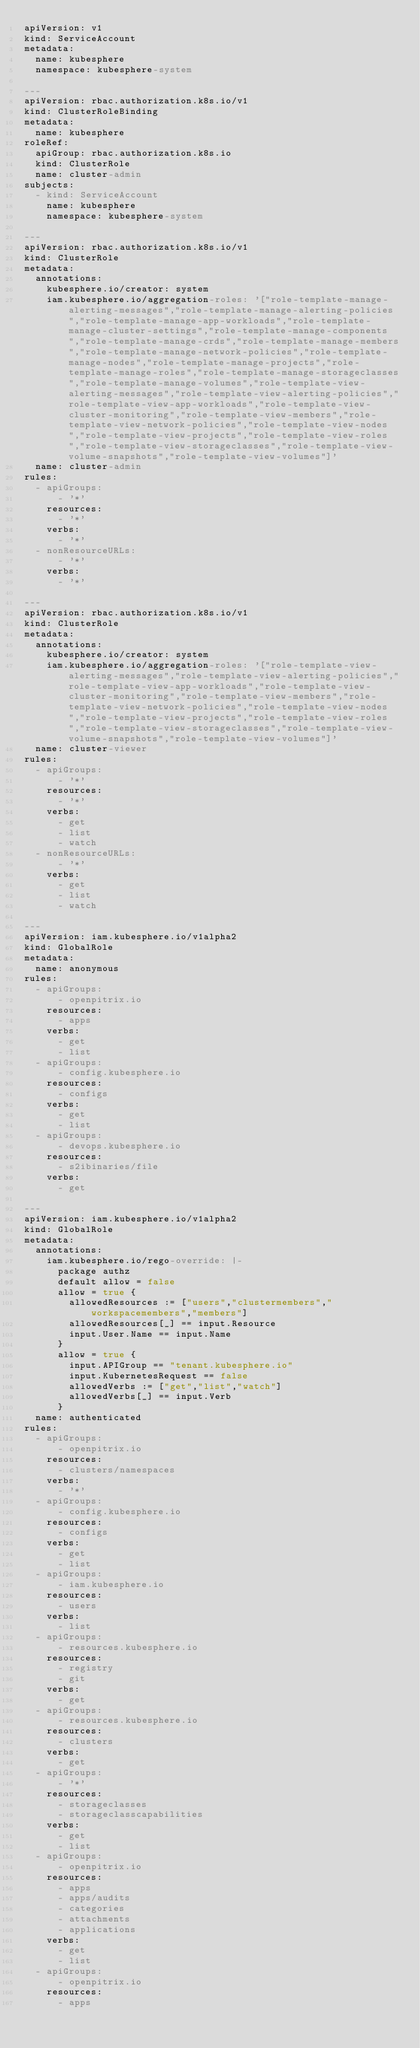<code> <loc_0><loc_0><loc_500><loc_500><_YAML_>apiVersion: v1
kind: ServiceAccount
metadata:
  name: kubesphere
  namespace: kubesphere-system

---
apiVersion: rbac.authorization.k8s.io/v1
kind: ClusterRoleBinding
metadata:
  name: kubesphere
roleRef:
  apiGroup: rbac.authorization.k8s.io
  kind: ClusterRole
  name: cluster-admin
subjects:
  - kind: ServiceAccount
    name: kubesphere
    namespace: kubesphere-system

---
apiVersion: rbac.authorization.k8s.io/v1
kind: ClusterRole
metadata:
  annotations:
    kubesphere.io/creator: system
    iam.kubesphere.io/aggregation-roles: '["role-template-manage-alerting-messages","role-template-manage-alerting-policies","role-template-manage-app-workloads","role-template-manage-cluster-settings","role-template-manage-components","role-template-manage-crds","role-template-manage-members","role-template-manage-network-policies","role-template-manage-nodes","role-template-manage-projects","role-template-manage-roles","role-template-manage-storageclasses","role-template-manage-volumes","role-template-view-alerting-messages","role-template-view-alerting-policies","role-template-view-app-workloads","role-template-view-cluster-monitoring","role-template-view-members","role-template-view-network-policies","role-template-view-nodes","role-template-view-projects","role-template-view-roles","role-template-view-storageclasses","role-template-view-volume-snapshots","role-template-view-volumes"]'
  name: cluster-admin
rules:
  - apiGroups:
      - '*'
    resources:
      - '*'
    verbs:
      - '*'
  - nonResourceURLs:
      - '*'
    verbs:
      - '*'

---
apiVersion: rbac.authorization.k8s.io/v1
kind: ClusterRole
metadata:
  annotations:
    kubesphere.io/creator: system
    iam.kubesphere.io/aggregation-roles: '["role-template-view-alerting-messages","role-template-view-alerting-policies","role-template-view-app-workloads","role-template-view-cluster-monitoring","role-template-view-members","role-template-view-network-policies","role-template-view-nodes","role-template-view-projects","role-template-view-roles","role-template-view-storageclasses","role-template-view-volume-snapshots","role-template-view-volumes"]'
  name: cluster-viewer
rules:
  - apiGroups:
      - '*'
    resources:
      - '*'
    verbs:
      - get
      - list
      - watch
  - nonResourceURLs:
      - '*'
    verbs:
      - get
      - list
      - watch

---
apiVersion: iam.kubesphere.io/v1alpha2
kind: GlobalRole
metadata:
  name: anonymous
rules:
  - apiGroups:
      - openpitrix.io
    resources:
      - apps
    verbs:
      - get
      - list
  - apiGroups:
      - config.kubesphere.io
    resources:
      - configs
    verbs:
      - get
      - list
  - apiGroups:
      - devops.kubesphere.io
    resources:
      - s2ibinaries/file
    verbs:
      - get

---
apiVersion: iam.kubesphere.io/v1alpha2
kind: GlobalRole
metadata:
  annotations:
    iam.kubesphere.io/rego-override: |-
      package authz
      default allow = false
      allow = true {
        allowedResources := ["users","clustermembers","workspacemembers","members"]
        allowedResources[_] == input.Resource
        input.User.Name == input.Name
      }
      allow = true {
        input.APIGroup == "tenant.kubesphere.io"
        input.KubernetesRequest == false
        allowedVerbs := ["get","list","watch"]
        allowedVerbs[_] == input.Verb
      }
  name: authenticated
rules:
  - apiGroups:
      - openpitrix.io
    resources:
      - clusters/namespaces
    verbs:
      - '*'
  - apiGroups:
      - config.kubesphere.io
    resources:
      - configs
    verbs:
      - get
      - list
  - apiGroups:
      - iam.kubesphere.io
    resources:
      - users
    verbs:
      - list
  - apiGroups:
      - resources.kubesphere.io
    resources:
      - registry
      - git
    verbs:
      - get
  - apiGroups:
      - resources.kubesphere.io
    resources:
      - clusters
    verbs:
      - get
  - apiGroups:
      - '*'
    resources:
      - storageclasses
      - storageclasscapabilities
    verbs:
      - get
      - list
  - apiGroups:
      - openpitrix.io
    resources:
      - apps
      - apps/audits
      - categories
      - attachments
      - applications
    verbs:
      - get
      - list
  - apiGroups:
      - openpitrix.io
    resources:
      - apps</code> 